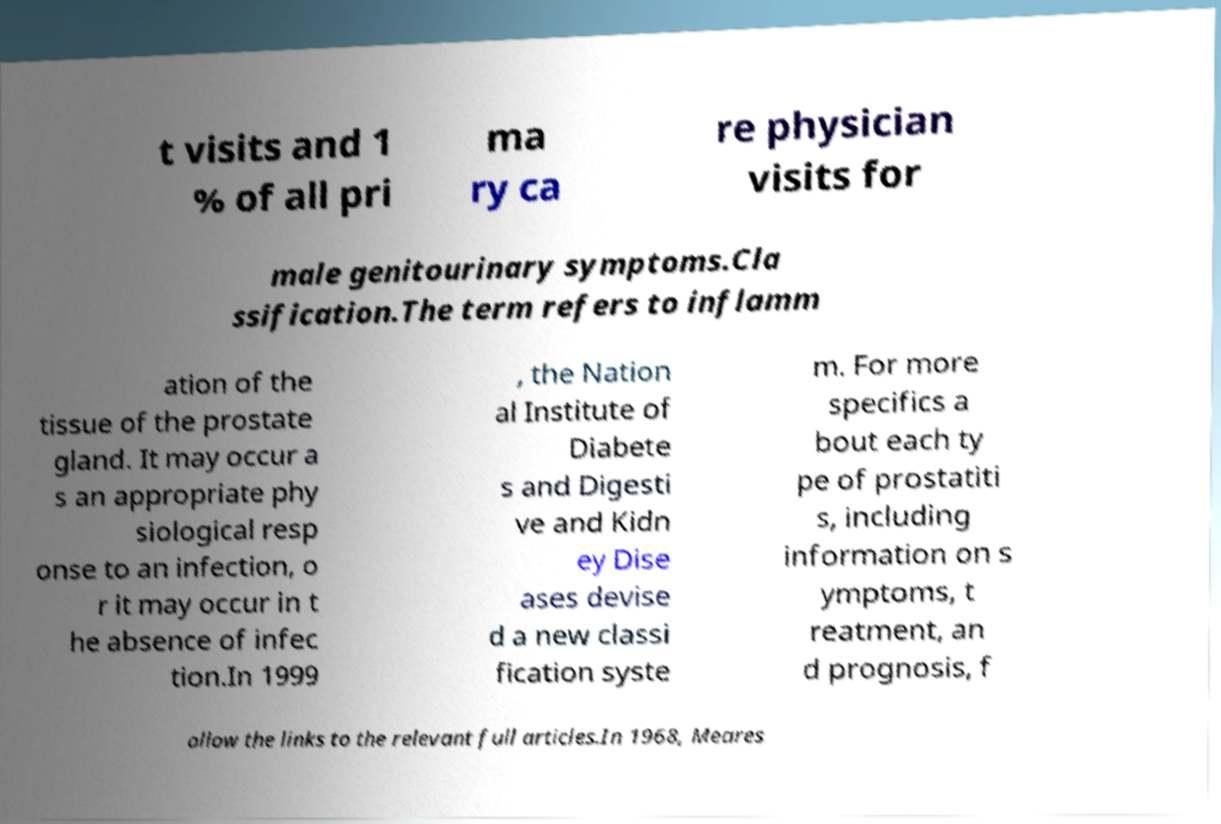There's text embedded in this image that I need extracted. Can you transcribe it verbatim? t visits and 1 % of all pri ma ry ca re physician visits for male genitourinary symptoms.Cla ssification.The term refers to inflamm ation of the tissue of the prostate gland. It may occur a s an appropriate phy siological resp onse to an infection, o r it may occur in t he absence of infec tion.In 1999 , the Nation al Institute of Diabete s and Digesti ve and Kidn ey Dise ases devise d a new classi fication syste m. For more specifics a bout each ty pe of prostatiti s, including information on s ymptoms, t reatment, an d prognosis, f ollow the links to the relevant full articles.In 1968, Meares 